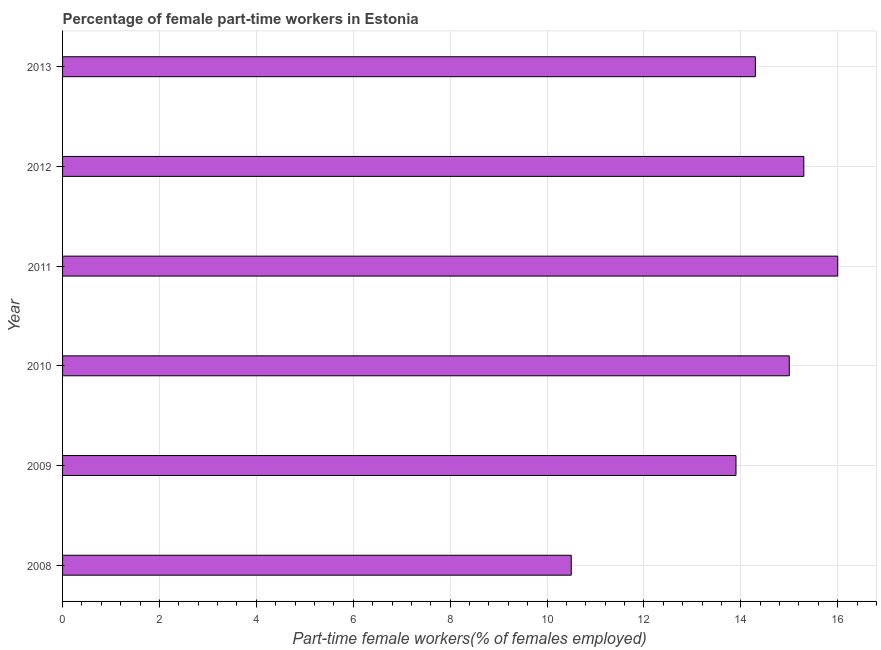What is the title of the graph?
Ensure brevity in your answer.  Percentage of female part-time workers in Estonia. What is the label or title of the X-axis?
Your answer should be very brief. Part-time female workers(% of females employed). What is the label or title of the Y-axis?
Ensure brevity in your answer.  Year. What is the percentage of part-time female workers in 2009?
Your answer should be very brief. 13.9. Across all years, what is the maximum percentage of part-time female workers?
Make the answer very short. 16. Across all years, what is the minimum percentage of part-time female workers?
Ensure brevity in your answer.  10.5. What is the sum of the percentage of part-time female workers?
Your answer should be compact. 85. What is the average percentage of part-time female workers per year?
Give a very brief answer. 14.17. What is the median percentage of part-time female workers?
Provide a succinct answer. 14.65. Do a majority of the years between 2011 and 2012 (inclusive) have percentage of part-time female workers greater than 3.6 %?
Keep it short and to the point. Yes. What is the ratio of the percentage of part-time female workers in 2012 to that in 2013?
Offer a very short reply. 1.07. Is the percentage of part-time female workers in 2009 less than that in 2013?
Offer a very short reply. Yes. How many bars are there?
Give a very brief answer. 6. How many years are there in the graph?
Give a very brief answer. 6. What is the Part-time female workers(% of females employed) of 2008?
Offer a very short reply. 10.5. What is the Part-time female workers(% of females employed) of 2009?
Make the answer very short. 13.9. What is the Part-time female workers(% of females employed) of 2012?
Offer a very short reply. 15.3. What is the Part-time female workers(% of females employed) in 2013?
Make the answer very short. 14.3. What is the difference between the Part-time female workers(% of females employed) in 2008 and 2009?
Your response must be concise. -3.4. What is the difference between the Part-time female workers(% of females employed) in 2008 and 2010?
Offer a terse response. -4.5. What is the difference between the Part-time female workers(% of females employed) in 2009 and 2010?
Provide a short and direct response. -1.1. What is the difference between the Part-time female workers(% of females employed) in 2009 and 2011?
Keep it short and to the point. -2.1. What is the difference between the Part-time female workers(% of females employed) in 2009 and 2012?
Make the answer very short. -1.4. What is the difference between the Part-time female workers(% of females employed) in 2009 and 2013?
Provide a short and direct response. -0.4. What is the difference between the Part-time female workers(% of females employed) in 2010 and 2011?
Provide a short and direct response. -1. What is the difference between the Part-time female workers(% of females employed) in 2010 and 2013?
Your response must be concise. 0.7. What is the ratio of the Part-time female workers(% of females employed) in 2008 to that in 2009?
Your response must be concise. 0.76. What is the ratio of the Part-time female workers(% of females employed) in 2008 to that in 2011?
Provide a succinct answer. 0.66. What is the ratio of the Part-time female workers(% of females employed) in 2008 to that in 2012?
Your response must be concise. 0.69. What is the ratio of the Part-time female workers(% of females employed) in 2008 to that in 2013?
Offer a terse response. 0.73. What is the ratio of the Part-time female workers(% of females employed) in 2009 to that in 2010?
Make the answer very short. 0.93. What is the ratio of the Part-time female workers(% of females employed) in 2009 to that in 2011?
Keep it short and to the point. 0.87. What is the ratio of the Part-time female workers(% of females employed) in 2009 to that in 2012?
Make the answer very short. 0.91. What is the ratio of the Part-time female workers(% of females employed) in 2010 to that in 2011?
Give a very brief answer. 0.94. What is the ratio of the Part-time female workers(% of females employed) in 2010 to that in 2012?
Provide a succinct answer. 0.98. What is the ratio of the Part-time female workers(% of females employed) in 2010 to that in 2013?
Give a very brief answer. 1.05. What is the ratio of the Part-time female workers(% of females employed) in 2011 to that in 2012?
Provide a short and direct response. 1.05. What is the ratio of the Part-time female workers(% of females employed) in 2011 to that in 2013?
Ensure brevity in your answer.  1.12. What is the ratio of the Part-time female workers(% of females employed) in 2012 to that in 2013?
Keep it short and to the point. 1.07. 